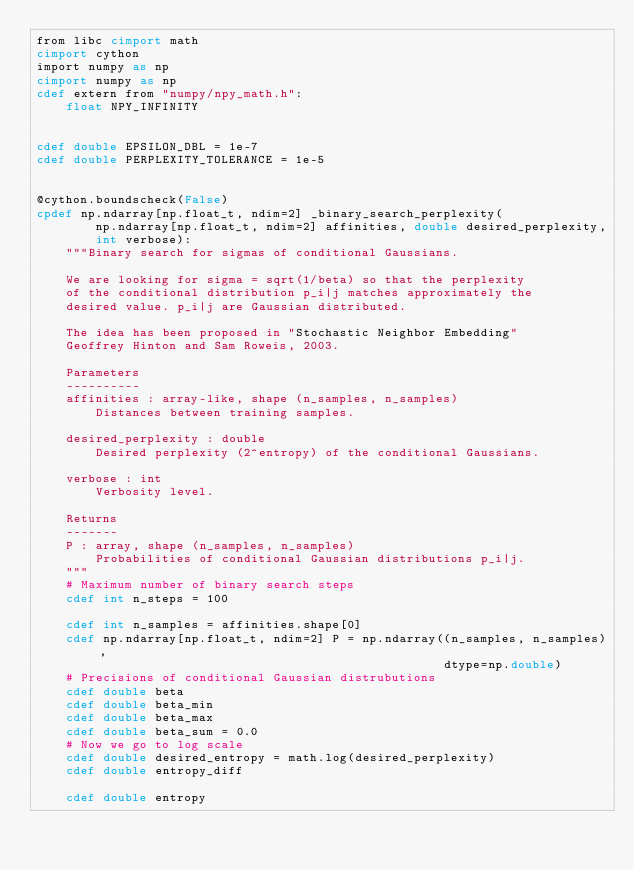Convert code to text. <code><loc_0><loc_0><loc_500><loc_500><_Cython_>from libc cimport math
cimport cython
import numpy as np
cimport numpy as np
cdef extern from "numpy/npy_math.h":
    float NPY_INFINITY


cdef double EPSILON_DBL = 1e-7
cdef double PERPLEXITY_TOLERANCE = 1e-5


@cython.boundscheck(False)
cpdef np.ndarray[np.float_t, ndim=2] _binary_search_perplexity(
        np.ndarray[np.float_t, ndim=2] affinities, double desired_perplexity,
        int verbose):
    """Binary search for sigmas of conditional Gaussians.

    We are looking for sigma = sqrt(1/beta) so that the perplexity
    of the conditional distribution p_i|j matches approximately the
    desired value. p_i|j are Gaussian distributed.

    The idea has been proposed in "Stochastic Neighbor Embedding"
    Geoffrey Hinton and Sam Roweis, 2003.

    Parameters
    ----------
    affinities : array-like, shape (n_samples, n_samples)
        Distances between training samples.

    desired_perplexity : double
        Desired perplexity (2^entropy) of the conditional Gaussians.

    verbose : int
        Verbosity level.

    Returns
    -------
    P : array, shape (n_samples, n_samples)
        Probabilities of conditional Gaussian distributions p_i|j.
    """
    # Maximum number of binary search steps
    cdef int n_steps = 100

    cdef int n_samples = affinities.shape[0]
    cdef np.ndarray[np.float_t, ndim=2] P = np.ndarray((n_samples, n_samples),
                                                       dtype=np.double)
    # Precisions of conditional Gaussian distrubutions
    cdef double beta
    cdef double beta_min
    cdef double beta_max
    cdef double beta_sum = 0.0
    # Now we go to log scale
    cdef double desired_entropy = math.log(desired_perplexity)
    cdef double entropy_diff

    cdef double entropy</code> 